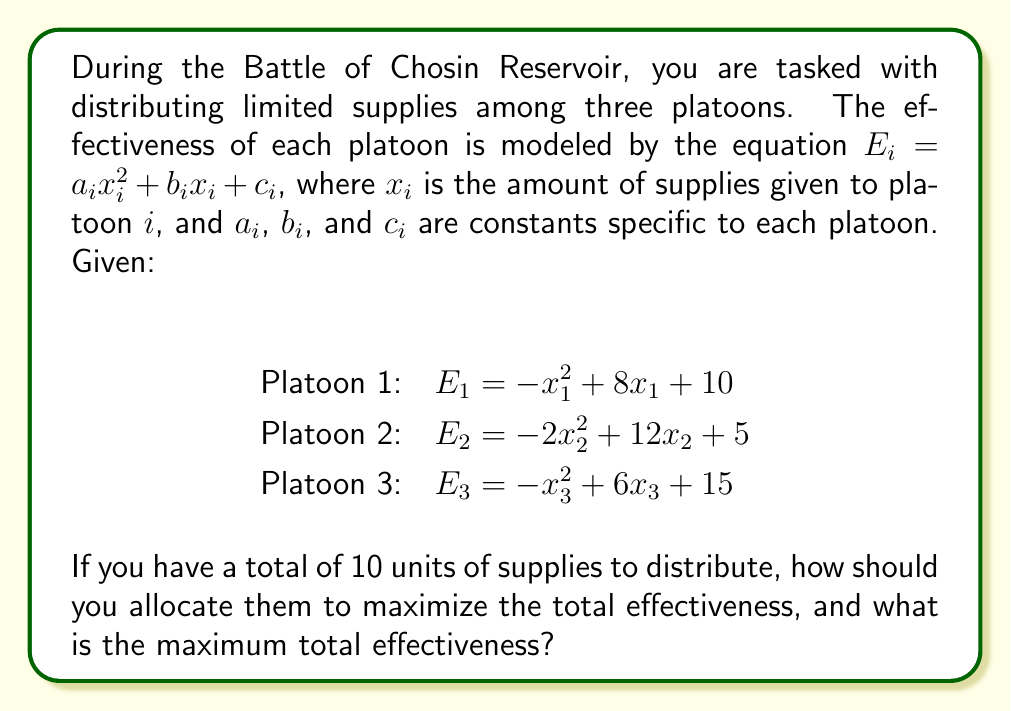Provide a solution to this math problem. To solve this problem, we'll use the method of Lagrange multipliers:

1) Let's define our objective function:
   $f(x_1, x_2, x_3) = E_1 + E_2 + E_3 = (-x_1^2 + 8x_1 + 10) + (-2x_2^2 + 12x_2 + 5) + (-x_3^2 + 6x_3 + 15)$

2) Our constraint is:
   $g(x_1, x_2, x_3) = x_1 + x_2 + x_3 - 10 = 0$

3) We form the Lagrangian:
   $L(x_1, x_2, x_3, \lambda) = f(x_1, x_2, x_3) - \lambda g(x_1, x_2, x_3)$

4) We take partial derivatives and set them to zero:
   $\frac{\partial L}{\partial x_1} = -2x_1 + 8 - \lambda = 0$
   $\frac{\partial L}{\partial x_2} = -4x_2 + 12 - \lambda = 0$
   $\frac{\partial L}{\partial x_3} = -2x_3 + 6 - \lambda = 0$
   $\frac{\partial L}{\partial \lambda} = x_1 + x_2 + x_3 - 10 = 0$

5) From these equations:
   $x_1 = 4 - \frac{\lambda}{2}$
   $x_2 = 3 - \frac{\lambda}{4}$
   $x_3 = 3 - \frac{\lambda}{2}$

6) Substituting these into the constraint equation:
   $(4 - \frac{\lambda}{2}) + (3 - \frac{\lambda}{4}) + (3 - \frac{\lambda}{2}) = 10$
   $10 - \frac{5\lambda}{4} = 10$
   $\lambda = 0$

7) Therefore:
   $x_1 = 4$
   $x_2 = 3$
   $x_3 = 3$

8) The maximum total effectiveness is:
   $E_{total} = (-4^2 + 8(4) + 10) + (-2(3)^2 + 12(3) + 5) + (-3^2 + 6(3) + 15)$
              $= 30 + 23 + 24 = 77$
Answer: Distribute 4 units to Platoon 1, 3 units to Platoon 2, and 3 units to Platoon 3. Maximum total effectiveness: 77. 